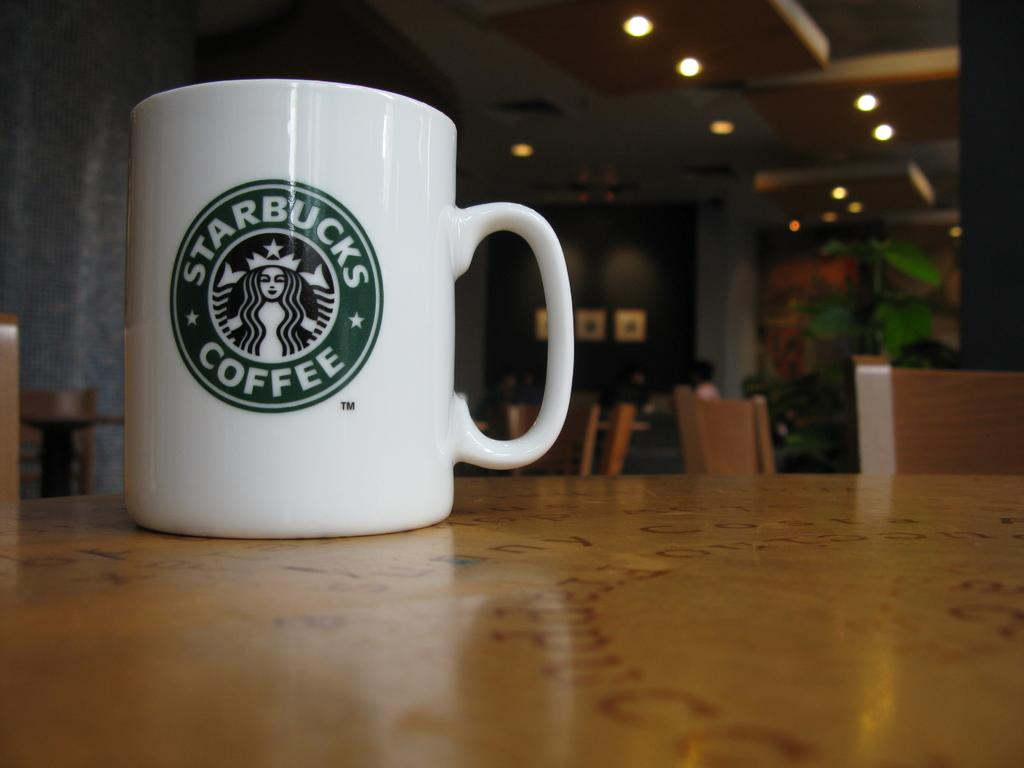<image>
Provide a brief description of the given image. White Starbucks coffee mug with green logo on table 